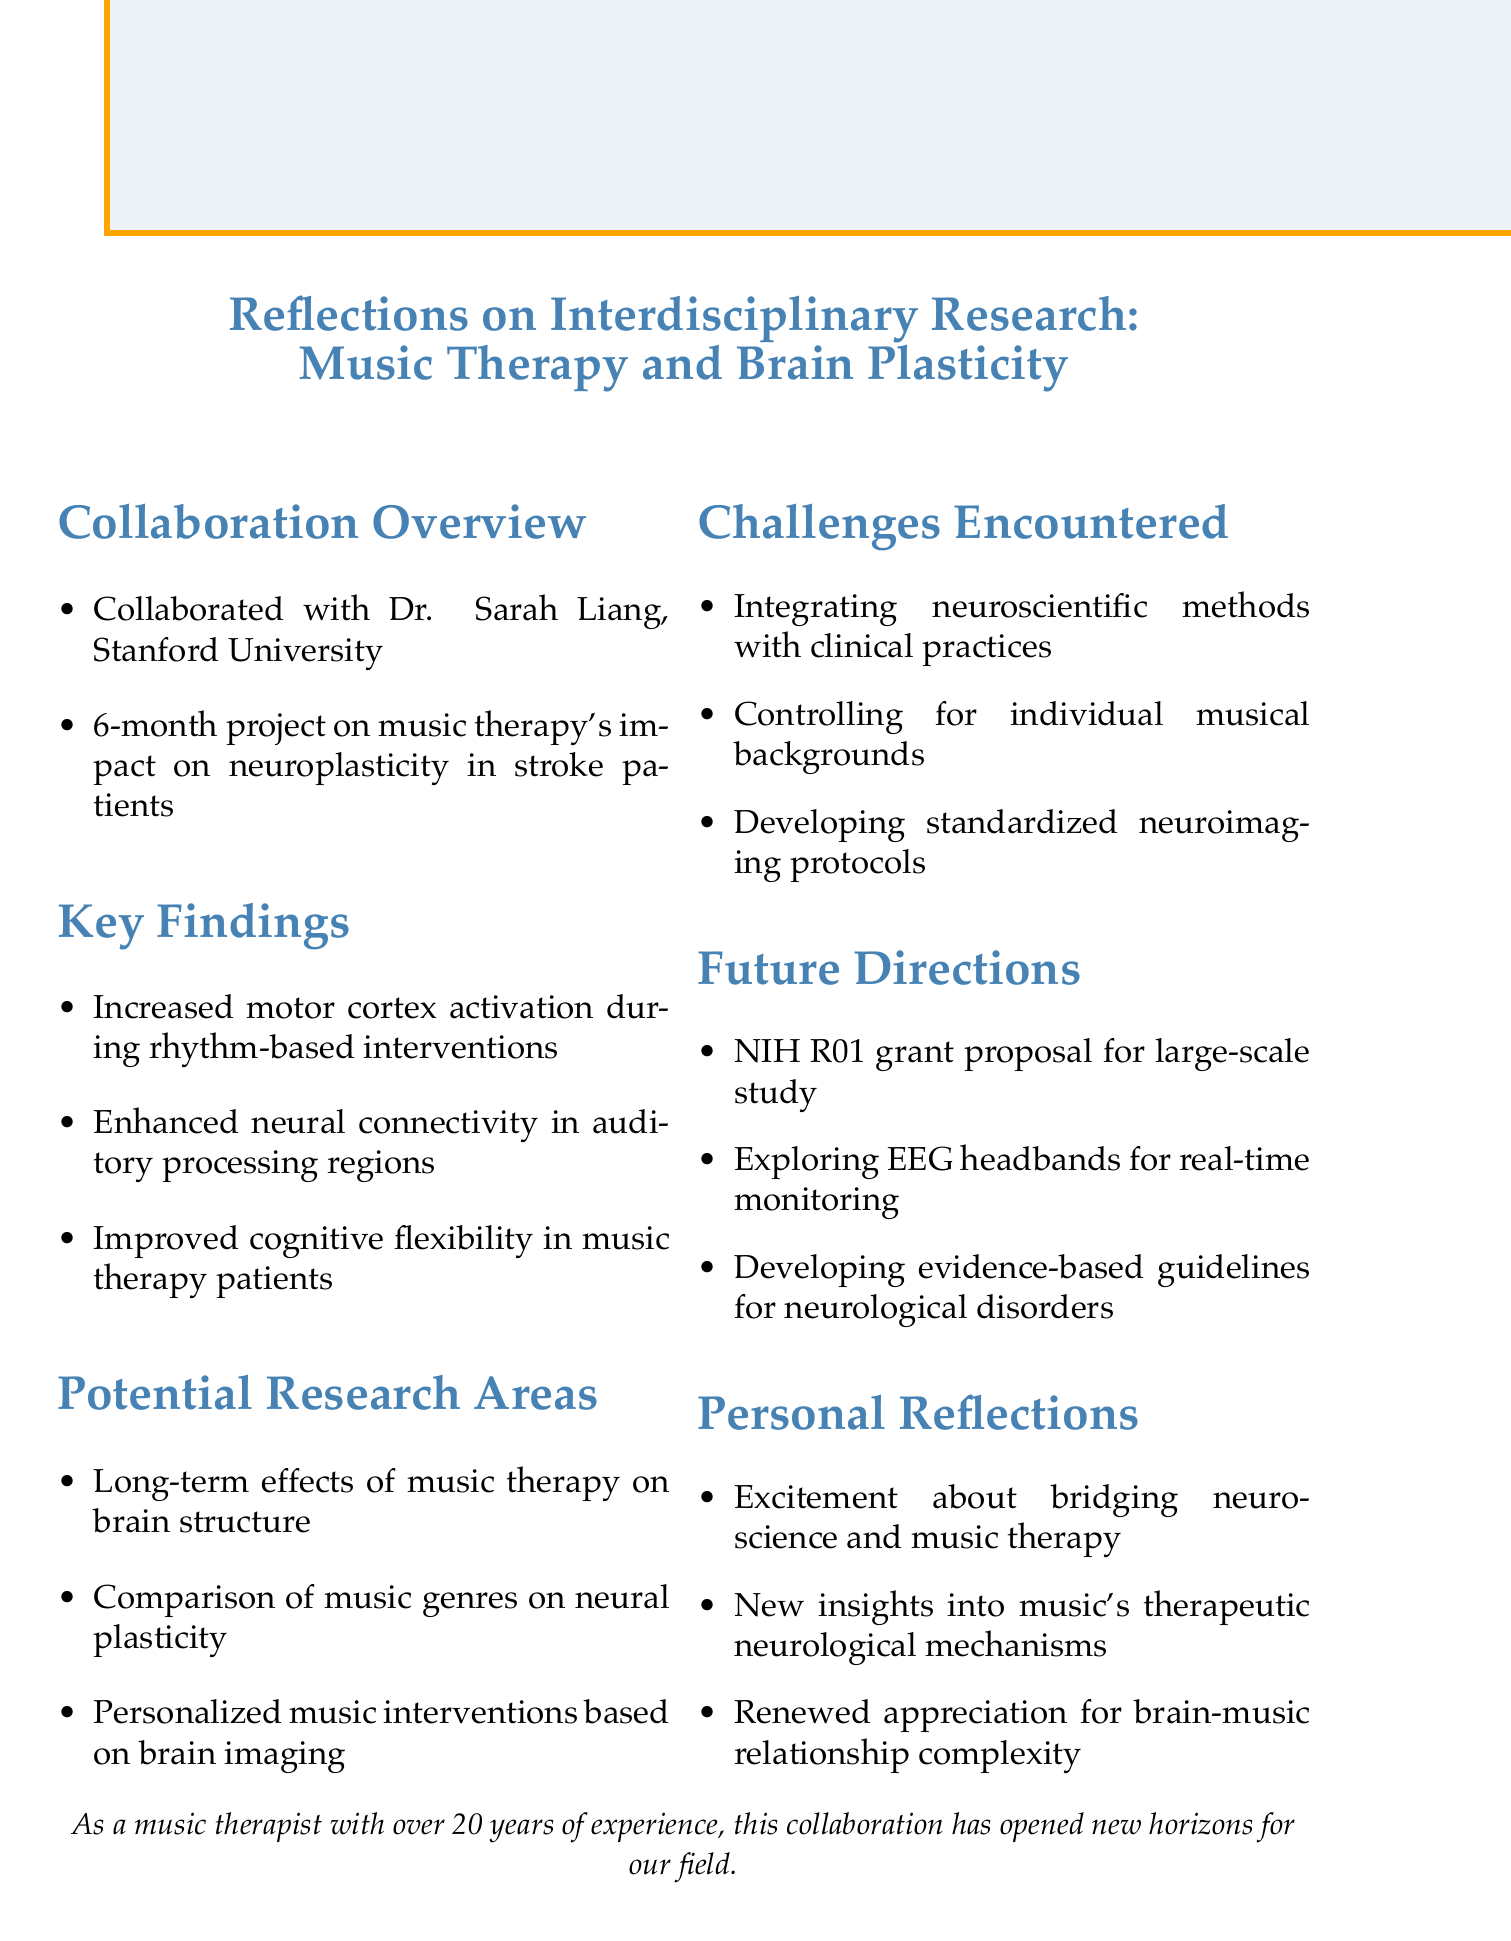What is the name of the collaborating neuroscientist? The document states that the collaboration was with Dr. Sarah Liang from Stanford University.
Answer: Dr. Sarah Liang How long did the project last? The document mentions that the project duration was 6 months.
Answer: 6 months What was the research focus of the collaboration? The collaboration focused on music therapy's impact on neuroplasticity in stroke patients.
Answer: Music therapy's impact on neuroplasticity in stroke patients What is one key finding related to cognitive flexibility? The document notes that there was improved cognitive flexibility in patients undergoing music therapy.
Answer: Improved cognitive flexibility Name one challenge encountered during the project. The document lists several challenges, one of which is integrating neuroscientific methods with clinical music therapy practices.
Answer: Integrating neuroscientific methods with clinical practices What is one potential research area identified? The document suggests several potential research areas, one being the long-term effects of music therapy on brain structure.
Answer: Long-term effects of music therapy on brain structure What future direction involves technology integration? The document discusses exploring the use of EEG headbands for real-time monitoring during therapy sessions.
Answer: EEG headbands for real-time monitoring What personal reflection relates to the complexity of the brain-music relationship? The document expresses a renewed appreciation for the complexity of the brain-music relationship.
Answer: Renewed appreciation for the complexity of the brain-music relationship 